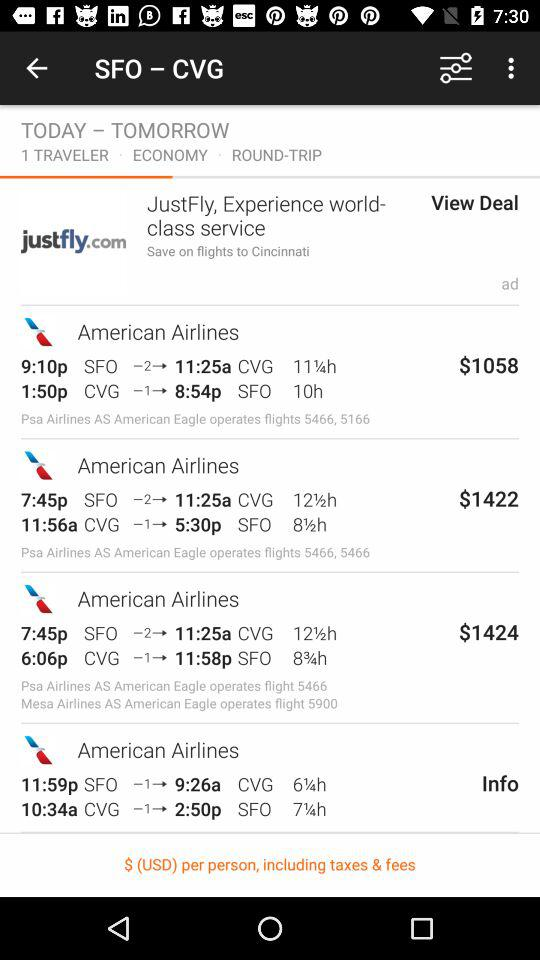What is the selected class? The selected class is "ECONOMY". 